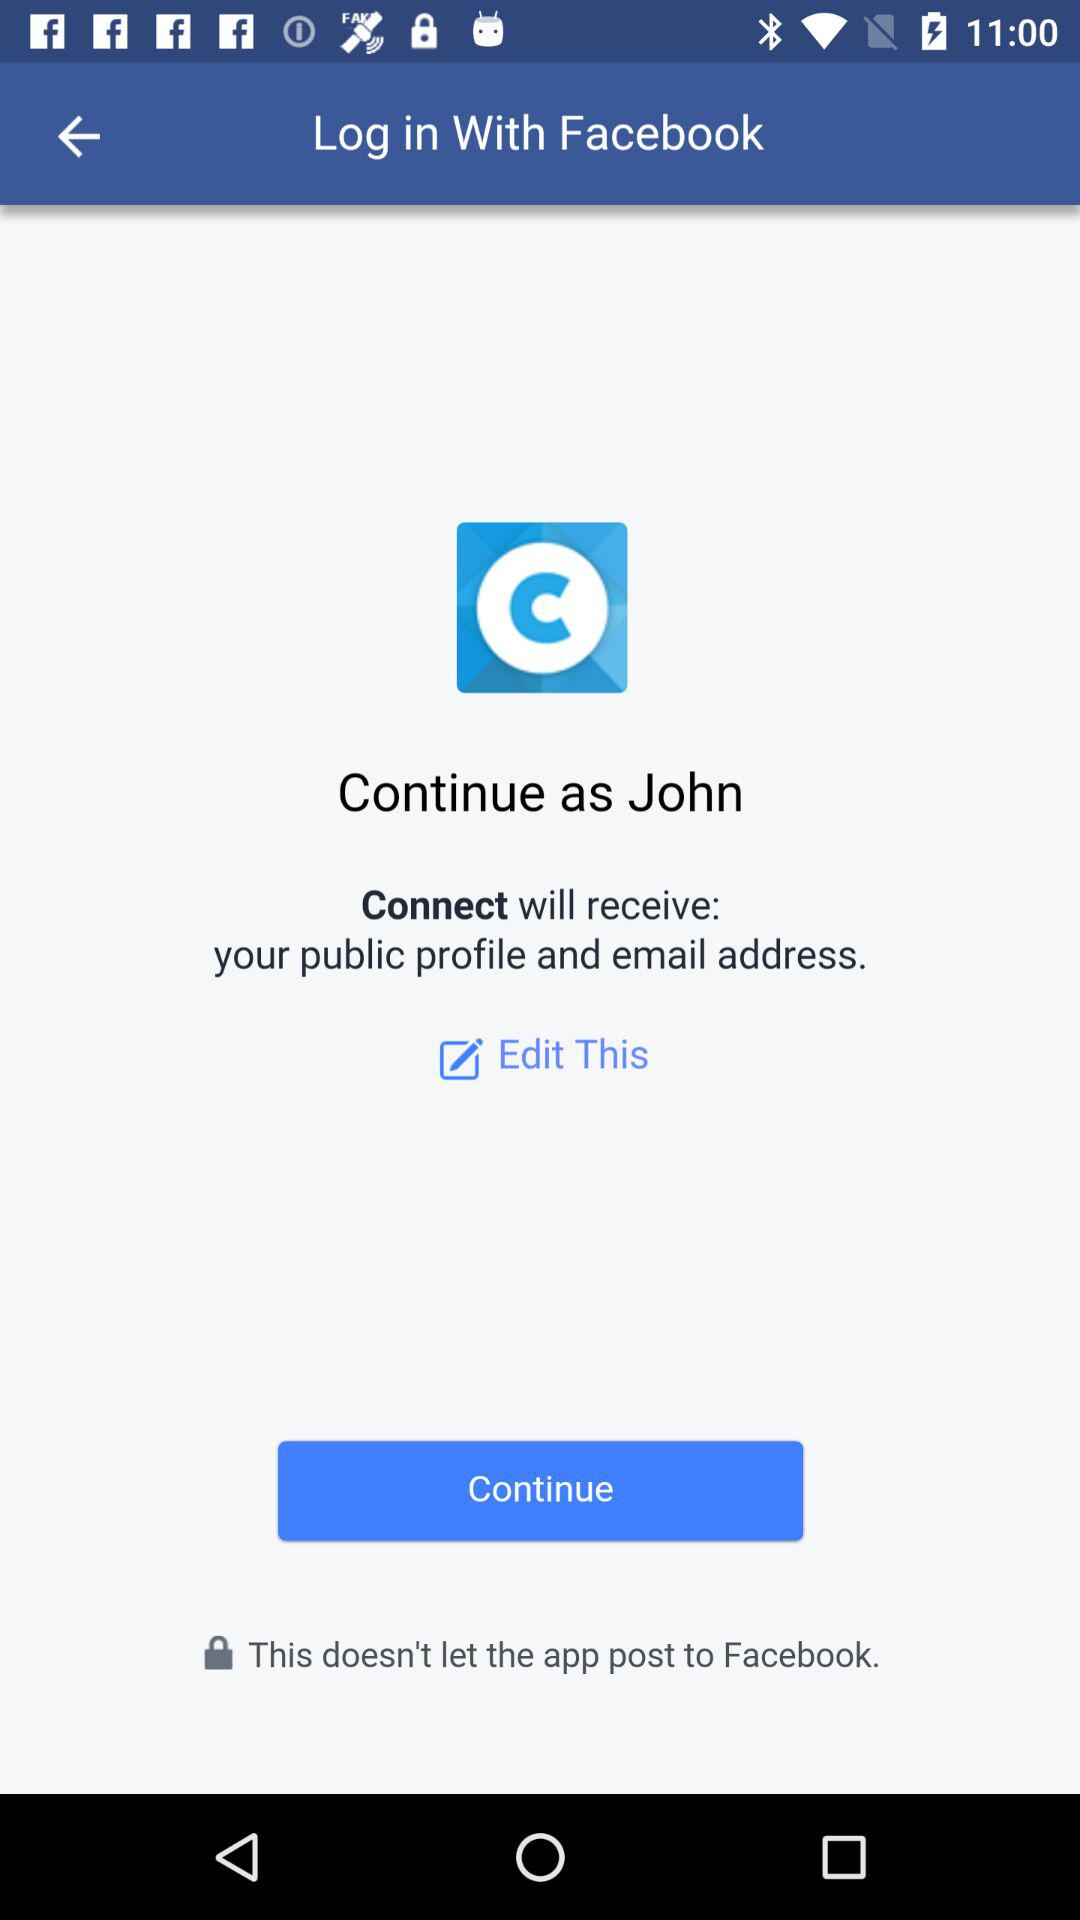What application is asking for permission? The application "Connect" is asking for permission. 